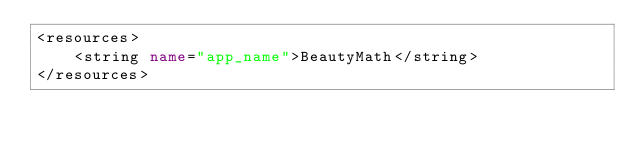Convert code to text. <code><loc_0><loc_0><loc_500><loc_500><_XML_><resources>
    <string name="app_name">BeautyMath</string>
</resources>
</code> 